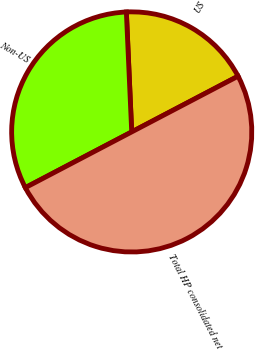Convert chart. <chart><loc_0><loc_0><loc_500><loc_500><pie_chart><fcel>US<fcel>Non-US<fcel>Total HP consolidated net<nl><fcel>18.03%<fcel>31.97%<fcel>50.0%<nl></chart> 